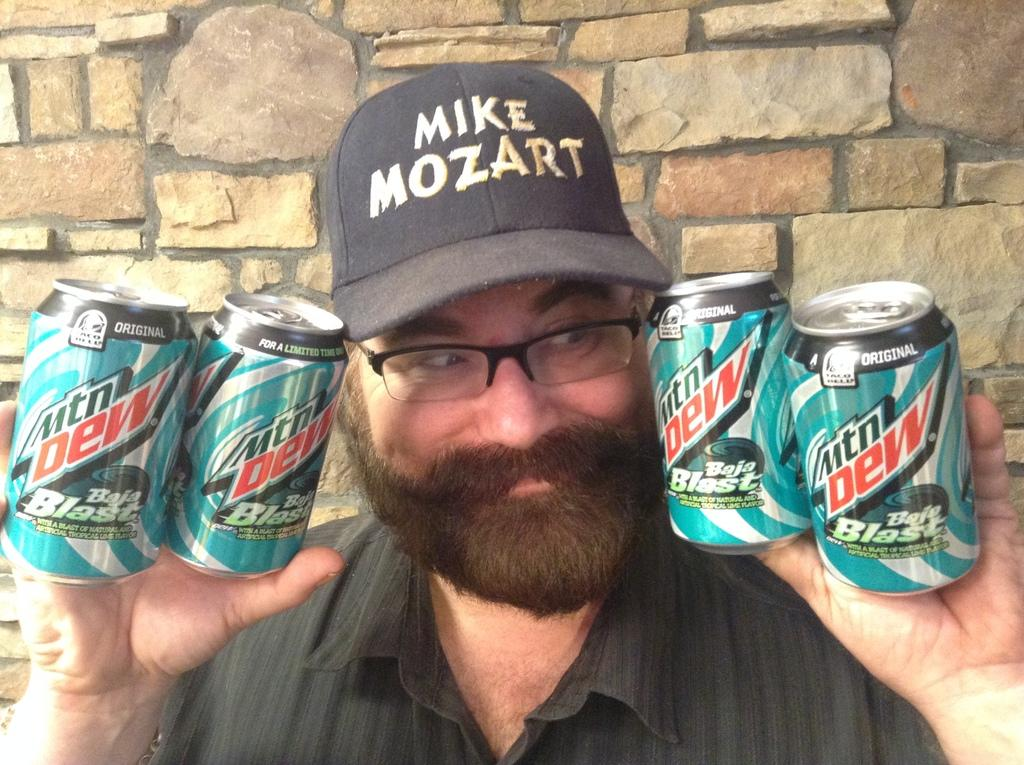Provide a one-sentence caption for the provided image. A man wearing a Mike Mozart hat holding four Mountain Dews. 